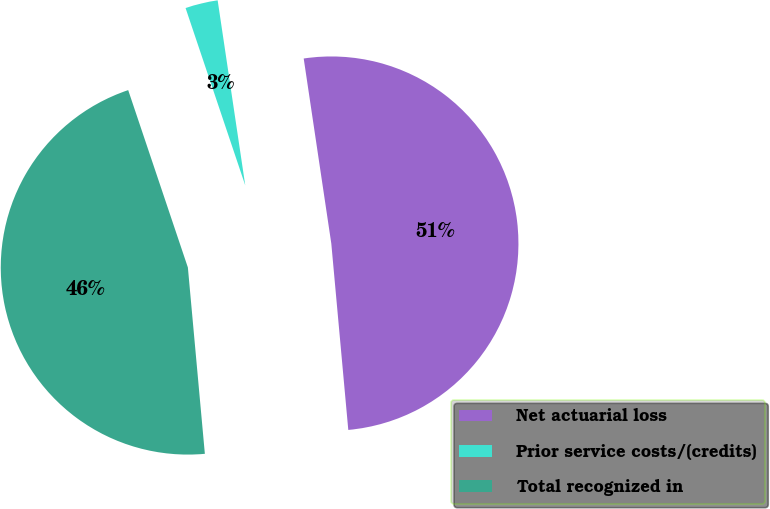Convert chart to OTSL. <chart><loc_0><loc_0><loc_500><loc_500><pie_chart><fcel>Net actuarial loss<fcel>Prior service costs/(credits)<fcel>Total recognized in<nl><fcel>50.91%<fcel>2.81%<fcel>46.28%<nl></chart> 